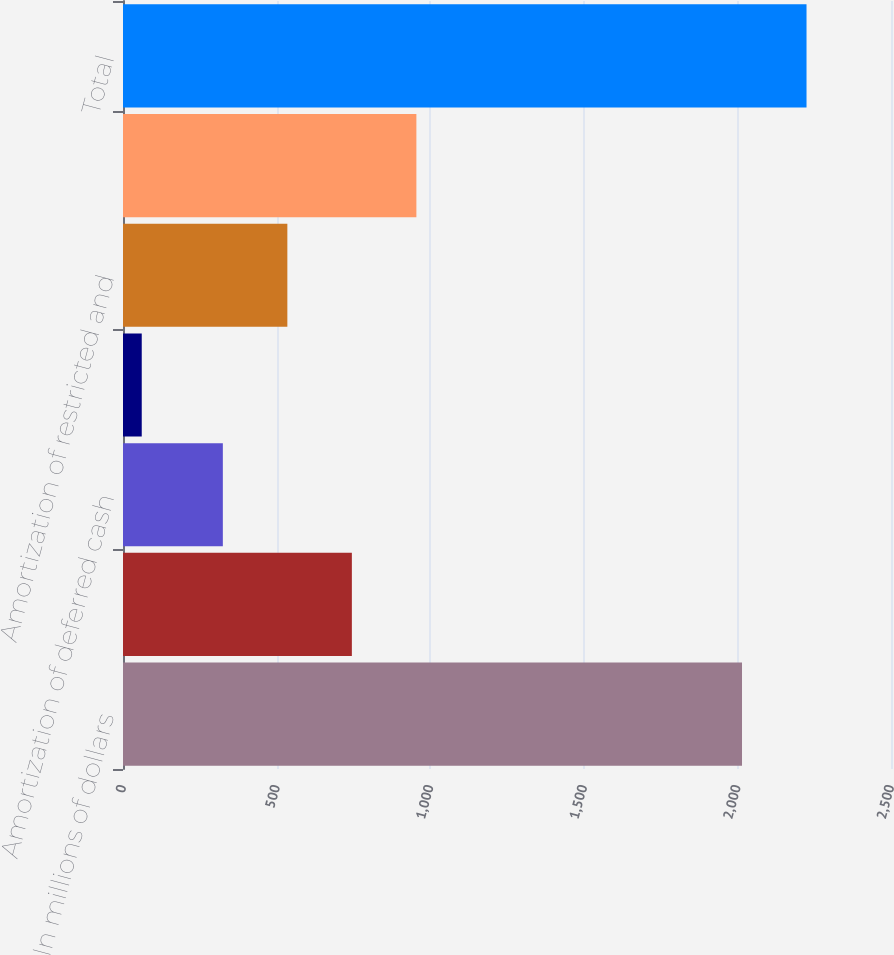<chart> <loc_0><loc_0><loc_500><loc_500><bar_chart><fcel>In millions of dollars<fcel>Charges for estimated awards<fcel>Amortization of deferred cash<fcel>Immediately vested stock award<fcel>Amortization of restricted and<fcel>Other variable incentive<fcel>Total<nl><fcel>2015<fcel>745<fcel>325<fcel>61<fcel>535<fcel>955<fcel>2225<nl></chart> 